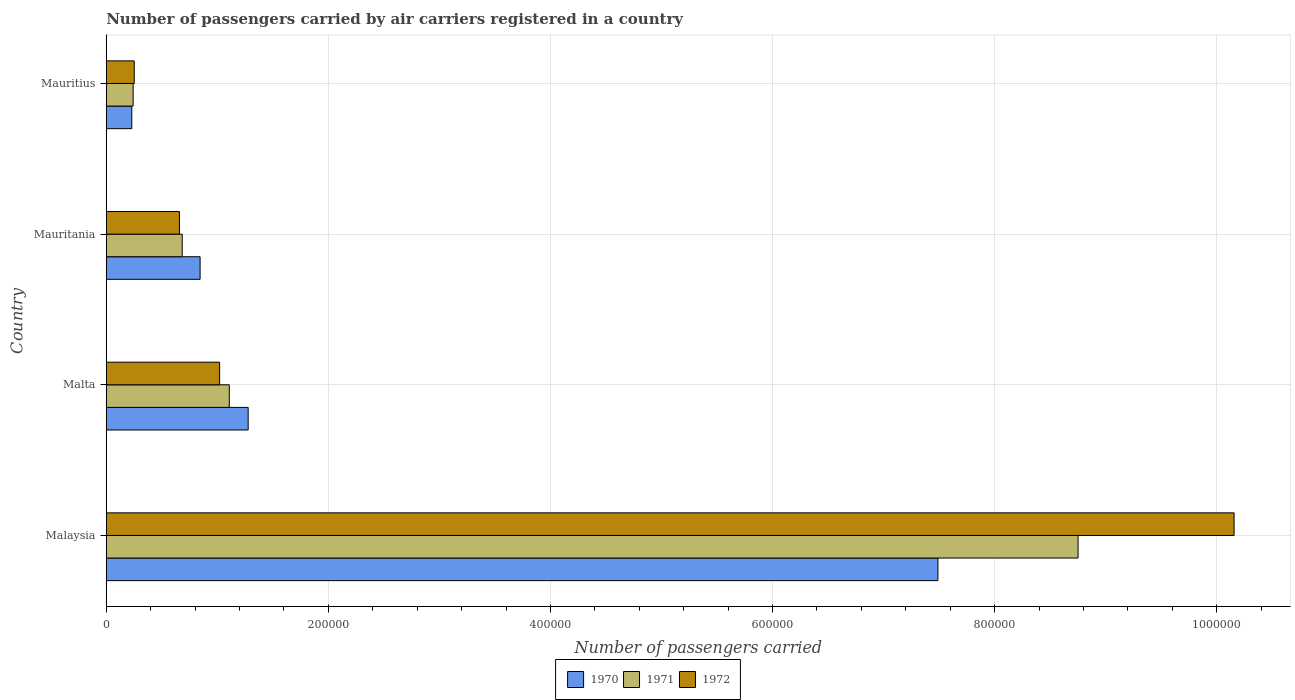How many groups of bars are there?
Your response must be concise. 4. Are the number of bars per tick equal to the number of legend labels?
Offer a very short reply. Yes. Are the number of bars on each tick of the Y-axis equal?
Keep it short and to the point. Yes. How many bars are there on the 1st tick from the top?
Make the answer very short. 3. What is the label of the 4th group of bars from the top?
Keep it short and to the point. Malaysia. In how many cases, is the number of bars for a given country not equal to the number of legend labels?
Ensure brevity in your answer.  0. What is the number of passengers carried by air carriers in 1972 in Malta?
Your answer should be very brief. 1.02e+05. Across all countries, what is the maximum number of passengers carried by air carriers in 1970?
Your answer should be compact. 7.49e+05. Across all countries, what is the minimum number of passengers carried by air carriers in 1971?
Keep it short and to the point. 2.42e+04. In which country was the number of passengers carried by air carriers in 1972 maximum?
Make the answer very short. Malaysia. In which country was the number of passengers carried by air carriers in 1971 minimum?
Your answer should be compact. Mauritius. What is the total number of passengers carried by air carriers in 1971 in the graph?
Your answer should be compact. 1.08e+06. What is the difference between the number of passengers carried by air carriers in 1971 in Malaysia and that in Mauritania?
Ensure brevity in your answer.  8.07e+05. What is the difference between the number of passengers carried by air carriers in 1971 in Mauritius and the number of passengers carried by air carriers in 1972 in Malta?
Your answer should be very brief. -7.79e+04. What is the average number of passengers carried by air carriers in 1971 per country?
Offer a terse response. 2.70e+05. What is the difference between the number of passengers carried by air carriers in 1972 and number of passengers carried by air carriers in 1971 in Malaysia?
Offer a very short reply. 1.40e+05. What is the ratio of the number of passengers carried by air carriers in 1972 in Malta to that in Mauritania?
Offer a terse response. 1.55. Is the difference between the number of passengers carried by air carriers in 1972 in Malaysia and Malta greater than the difference between the number of passengers carried by air carriers in 1971 in Malaysia and Malta?
Provide a succinct answer. Yes. What is the difference between the highest and the second highest number of passengers carried by air carriers in 1970?
Your answer should be compact. 6.21e+05. What is the difference between the highest and the lowest number of passengers carried by air carriers in 1970?
Keep it short and to the point. 7.26e+05. In how many countries, is the number of passengers carried by air carriers in 1971 greater than the average number of passengers carried by air carriers in 1971 taken over all countries?
Give a very brief answer. 1. Are all the bars in the graph horizontal?
Make the answer very short. Yes. What is the difference between two consecutive major ticks on the X-axis?
Keep it short and to the point. 2.00e+05. Are the values on the major ticks of X-axis written in scientific E-notation?
Offer a very short reply. No. Does the graph contain any zero values?
Offer a terse response. No. Does the graph contain grids?
Give a very brief answer. Yes. Where does the legend appear in the graph?
Give a very brief answer. Bottom center. How many legend labels are there?
Your answer should be compact. 3. What is the title of the graph?
Keep it short and to the point. Number of passengers carried by air carriers registered in a country. Does "2013" appear as one of the legend labels in the graph?
Keep it short and to the point. No. What is the label or title of the X-axis?
Ensure brevity in your answer.  Number of passengers carried. What is the label or title of the Y-axis?
Your response must be concise. Country. What is the Number of passengers carried in 1970 in Malaysia?
Your answer should be very brief. 7.49e+05. What is the Number of passengers carried of 1971 in Malaysia?
Your response must be concise. 8.75e+05. What is the Number of passengers carried of 1972 in Malaysia?
Offer a very short reply. 1.02e+06. What is the Number of passengers carried in 1970 in Malta?
Your answer should be compact. 1.28e+05. What is the Number of passengers carried in 1971 in Malta?
Your answer should be compact. 1.11e+05. What is the Number of passengers carried of 1972 in Malta?
Offer a terse response. 1.02e+05. What is the Number of passengers carried of 1970 in Mauritania?
Offer a very short reply. 8.45e+04. What is the Number of passengers carried of 1971 in Mauritania?
Ensure brevity in your answer.  6.84e+04. What is the Number of passengers carried in 1972 in Mauritania?
Your answer should be very brief. 6.59e+04. What is the Number of passengers carried in 1970 in Mauritius?
Ensure brevity in your answer.  2.30e+04. What is the Number of passengers carried in 1971 in Mauritius?
Provide a short and direct response. 2.42e+04. What is the Number of passengers carried of 1972 in Mauritius?
Your response must be concise. 2.52e+04. Across all countries, what is the maximum Number of passengers carried of 1970?
Make the answer very short. 7.49e+05. Across all countries, what is the maximum Number of passengers carried of 1971?
Provide a short and direct response. 8.75e+05. Across all countries, what is the maximum Number of passengers carried in 1972?
Provide a short and direct response. 1.02e+06. Across all countries, what is the minimum Number of passengers carried in 1970?
Your response must be concise. 2.30e+04. Across all countries, what is the minimum Number of passengers carried of 1971?
Ensure brevity in your answer.  2.42e+04. Across all countries, what is the minimum Number of passengers carried in 1972?
Provide a short and direct response. 2.52e+04. What is the total Number of passengers carried in 1970 in the graph?
Make the answer very short. 9.84e+05. What is the total Number of passengers carried of 1971 in the graph?
Offer a very short reply. 1.08e+06. What is the total Number of passengers carried in 1972 in the graph?
Your answer should be compact. 1.21e+06. What is the difference between the Number of passengers carried of 1970 in Malaysia and that in Malta?
Provide a short and direct response. 6.21e+05. What is the difference between the Number of passengers carried of 1971 in Malaysia and that in Malta?
Ensure brevity in your answer.  7.64e+05. What is the difference between the Number of passengers carried in 1972 in Malaysia and that in Malta?
Keep it short and to the point. 9.14e+05. What is the difference between the Number of passengers carried in 1970 in Malaysia and that in Mauritania?
Provide a short and direct response. 6.64e+05. What is the difference between the Number of passengers carried in 1971 in Malaysia and that in Mauritania?
Keep it short and to the point. 8.07e+05. What is the difference between the Number of passengers carried in 1972 in Malaysia and that in Mauritania?
Give a very brief answer. 9.50e+05. What is the difference between the Number of passengers carried in 1970 in Malaysia and that in Mauritius?
Your answer should be compact. 7.26e+05. What is the difference between the Number of passengers carried in 1971 in Malaysia and that in Mauritius?
Ensure brevity in your answer.  8.51e+05. What is the difference between the Number of passengers carried in 1972 in Malaysia and that in Mauritius?
Keep it short and to the point. 9.90e+05. What is the difference between the Number of passengers carried of 1970 in Malta and that in Mauritania?
Provide a succinct answer. 4.33e+04. What is the difference between the Number of passengers carried in 1971 in Malta and that in Mauritania?
Your response must be concise. 4.24e+04. What is the difference between the Number of passengers carried in 1972 in Malta and that in Mauritania?
Your answer should be very brief. 3.62e+04. What is the difference between the Number of passengers carried of 1970 in Malta and that in Mauritius?
Your response must be concise. 1.05e+05. What is the difference between the Number of passengers carried in 1971 in Malta and that in Mauritius?
Give a very brief answer. 8.66e+04. What is the difference between the Number of passengers carried of 1972 in Malta and that in Mauritius?
Offer a very short reply. 7.69e+04. What is the difference between the Number of passengers carried in 1970 in Mauritania and that in Mauritius?
Your response must be concise. 6.15e+04. What is the difference between the Number of passengers carried of 1971 in Mauritania and that in Mauritius?
Your answer should be very brief. 4.42e+04. What is the difference between the Number of passengers carried in 1972 in Mauritania and that in Mauritius?
Give a very brief answer. 4.07e+04. What is the difference between the Number of passengers carried of 1970 in Malaysia and the Number of passengers carried of 1971 in Malta?
Keep it short and to the point. 6.38e+05. What is the difference between the Number of passengers carried of 1970 in Malaysia and the Number of passengers carried of 1972 in Malta?
Provide a succinct answer. 6.47e+05. What is the difference between the Number of passengers carried of 1971 in Malaysia and the Number of passengers carried of 1972 in Malta?
Your response must be concise. 7.73e+05. What is the difference between the Number of passengers carried in 1970 in Malaysia and the Number of passengers carried in 1971 in Mauritania?
Make the answer very short. 6.80e+05. What is the difference between the Number of passengers carried of 1970 in Malaysia and the Number of passengers carried of 1972 in Mauritania?
Ensure brevity in your answer.  6.83e+05. What is the difference between the Number of passengers carried in 1971 in Malaysia and the Number of passengers carried in 1972 in Mauritania?
Ensure brevity in your answer.  8.09e+05. What is the difference between the Number of passengers carried in 1970 in Malaysia and the Number of passengers carried in 1971 in Mauritius?
Make the answer very short. 7.25e+05. What is the difference between the Number of passengers carried of 1970 in Malaysia and the Number of passengers carried of 1972 in Mauritius?
Provide a succinct answer. 7.24e+05. What is the difference between the Number of passengers carried in 1971 in Malaysia and the Number of passengers carried in 1972 in Mauritius?
Keep it short and to the point. 8.50e+05. What is the difference between the Number of passengers carried of 1970 in Malta and the Number of passengers carried of 1971 in Mauritania?
Keep it short and to the point. 5.94e+04. What is the difference between the Number of passengers carried of 1970 in Malta and the Number of passengers carried of 1972 in Mauritania?
Offer a very short reply. 6.19e+04. What is the difference between the Number of passengers carried of 1971 in Malta and the Number of passengers carried of 1972 in Mauritania?
Keep it short and to the point. 4.49e+04. What is the difference between the Number of passengers carried of 1970 in Malta and the Number of passengers carried of 1971 in Mauritius?
Offer a terse response. 1.04e+05. What is the difference between the Number of passengers carried of 1970 in Malta and the Number of passengers carried of 1972 in Mauritius?
Ensure brevity in your answer.  1.03e+05. What is the difference between the Number of passengers carried of 1971 in Malta and the Number of passengers carried of 1972 in Mauritius?
Your answer should be compact. 8.56e+04. What is the difference between the Number of passengers carried in 1970 in Mauritania and the Number of passengers carried in 1971 in Mauritius?
Keep it short and to the point. 6.03e+04. What is the difference between the Number of passengers carried of 1970 in Mauritania and the Number of passengers carried of 1972 in Mauritius?
Offer a terse response. 5.93e+04. What is the difference between the Number of passengers carried in 1971 in Mauritania and the Number of passengers carried in 1972 in Mauritius?
Offer a very short reply. 4.32e+04. What is the average Number of passengers carried in 1970 per country?
Ensure brevity in your answer.  2.46e+05. What is the average Number of passengers carried of 1971 per country?
Ensure brevity in your answer.  2.70e+05. What is the average Number of passengers carried of 1972 per country?
Ensure brevity in your answer.  3.02e+05. What is the difference between the Number of passengers carried in 1970 and Number of passengers carried in 1971 in Malaysia?
Give a very brief answer. -1.26e+05. What is the difference between the Number of passengers carried in 1970 and Number of passengers carried in 1972 in Malaysia?
Offer a terse response. -2.67e+05. What is the difference between the Number of passengers carried in 1971 and Number of passengers carried in 1972 in Malaysia?
Your response must be concise. -1.40e+05. What is the difference between the Number of passengers carried of 1970 and Number of passengers carried of 1971 in Malta?
Your response must be concise. 1.70e+04. What is the difference between the Number of passengers carried of 1970 and Number of passengers carried of 1972 in Malta?
Provide a succinct answer. 2.57e+04. What is the difference between the Number of passengers carried of 1971 and Number of passengers carried of 1972 in Malta?
Keep it short and to the point. 8700. What is the difference between the Number of passengers carried of 1970 and Number of passengers carried of 1971 in Mauritania?
Offer a terse response. 1.61e+04. What is the difference between the Number of passengers carried in 1970 and Number of passengers carried in 1972 in Mauritania?
Your response must be concise. 1.86e+04. What is the difference between the Number of passengers carried of 1971 and Number of passengers carried of 1972 in Mauritania?
Ensure brevity in your answer.  2500. What is the difference between the Number of passengers carried of 1970 and Number of passengers carried of 1971 in Mauritius?
Your response must be concise. -1200. What is the difference between the Number of passengers carried in 1970 and Number of passengers carried in 1972 in Mauritius?
Ensure brevity in your answer.  -2200. What is the difference between the Number of passengers carried in 1971 and Number of passengers carried in 1972 in Mauritius?
Give a very brief answer. -1000. What is the ratio of the Number of passengers carried of 1970 in Malaysia to that in Malta?
Make the answer very short. 5.86. What is the ratio of the Number of passengers carried of 1971 in Malaysia to that in Malta?
Give a very brief answer. 7.9. What is the ratio of the Number of passengers carried of 1972 in Malaysia to that in Malta?
Your response must be concise. 9.95. What is the ratio of the Number of passengers carried of 1970 in Malaysia to that in Mauritania?
Your answer should be compact. 8.86. What is the ratio of the Number of passengers carried of 1971 in Malaysia to that in Mauritania?
Ensure brevity in your answer.  12.79. What is the ratio of the Number of passengers carried of 1972 in Malaysia to that in Mauritania?
Make the answer very short. 15.41. What is the ratio of the Number of passengers carried of 1970 in Malaysia to that in Mauritius?
Provide a short and direct response. 32.56. What is the ratio of the Number of passengers carried of 1971 in Malaysia to that in Mauritius?
Your answer should be very brief. 36.16. What is the ratio of the Number of passengers carried in 1972 in Malaysia to that in Mauritius?
Give a very brief answer. 40.3. What is the ratio of the Number of passengers carried of 1970 in Malta to that in Mauritania?
Provide a short and direct response. 1.51. What is the ratio of the Number of passengers carried in 1971 in Malta to that in Mauritania?
Keep it short and to the point. 1.62. What is the ratio of the Number of passengers carried in 1972 in Malta to that in Mauritania?
Provide a short and direct response. 1.55. What is the ratio of the Number of passengers carried of 1970 in Malta to that in Mauritius?
Keep it short and to the point. 5.56. What is the ratio of the Number of passengers carried in 1971 in Malta to that in Mauritius?
Your answer should be compact. 4.58. What is the ratio of the Number of passengers carried of 1972 in Malta to that in Mauritius?
Make the answer very short. 4.05. What is the ratio of the Number of passengers carried of 1970 in Mauritania to that in Mauritius?
Offer a very short reply. 3.67. What is the ratio of the Number of passengers carried in 1971 in Mauritania to that in Mauritius?
Offer a very short reply. 2.83. What is the ratio of the Number of passengers carried in 1972 in Mauritania to that in Mauritius?
Offer a terse response. 2.62. What is the difference between the highest and the second highest Number of passengers carried of 1970?
Provide a succinct answer. 6.21e+05. What is the difference between the highest and the second highest Number of passengers carried in 1971?
Keep it short and to the point. 7.64e+05. What is the difference between the highest and the second highest Number of passengers carried of 1972?
Offer a terse response. 9.14e+05. What is the difference between the highest and the lowest Number of passengers carried of 1970?
Your answer should be compact. 7.26e+05. What is the difference between the highest and the lowest Number of passengers carried of 1971?
Offer a very short reply. 8.51e+05. What is the difference between the highest and the lowest Number of passengers carried in 1972?
Provide a short and direct response. 9.90e+05. 